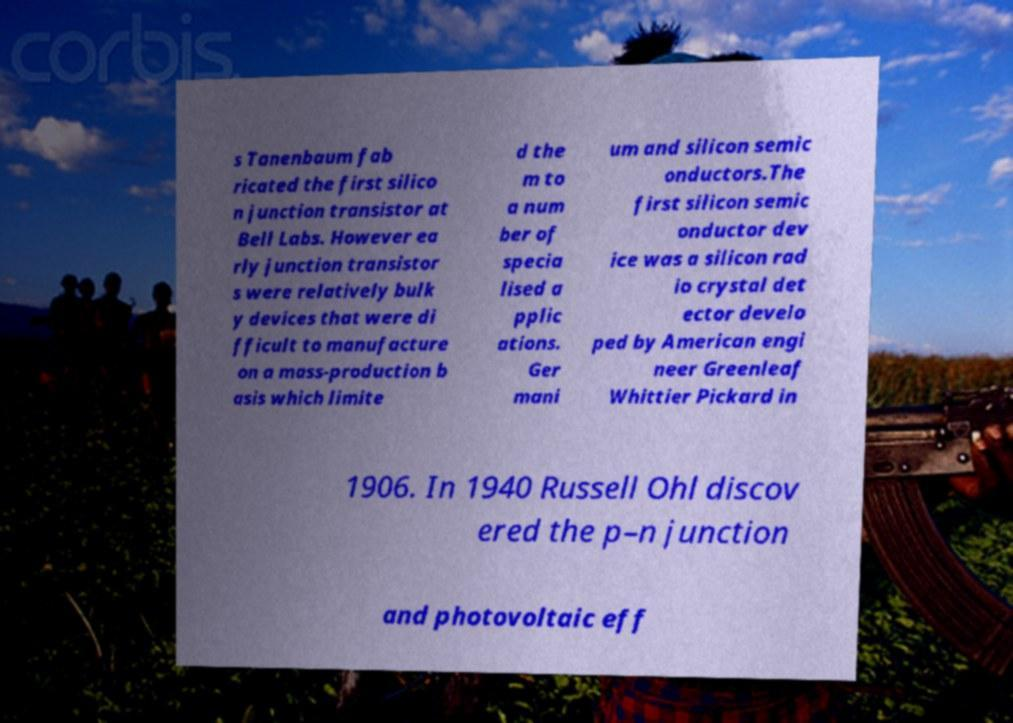Could you extract and type out the text from this image? s Tanenbaum fab ricated the first silico n junction transistor at Bell Labs. However ea rly junction transistor s were relatively bulk y devices that were di fficult to manufacture on a mass-production b asis which limite d the m to a num ber of specia lised a pplic ations. Ger mani um and silicon semic onductors.The first silicon semic onductor dev ice was a silicon rad io crystal det ector develo ped by American engi neer Greenleaf Whittier Pickard in 1906. In 1940 Russell Ohl discov ered the p–n junction and photovoltaic eff 